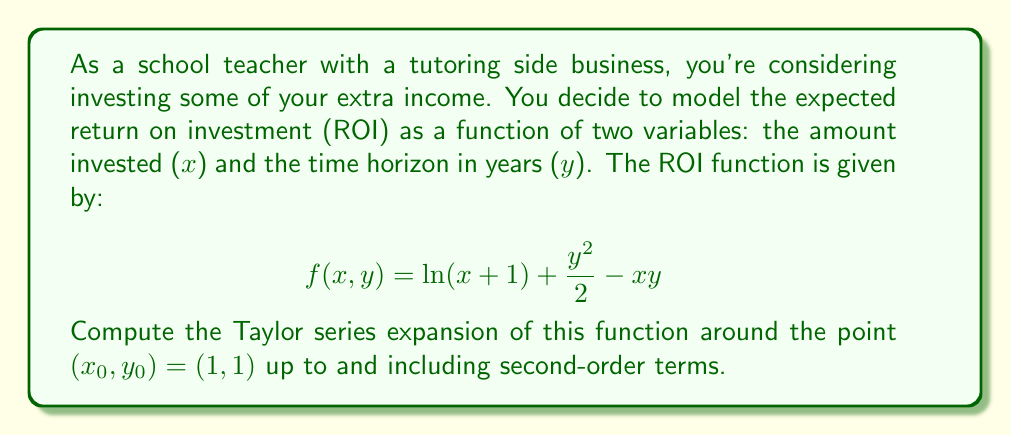Teach me how to tackle this problem. To find the Taylor series expansion of a multivariable function $f(x,y)$ around a point $(x_0, y_0)$, we use the formula:

$$f(x,y) \approx f(x_0, y_0) + f_x(x_0, y_0)(x-x_0) + f_y(x_0, y_0)(y-y_0) + \frac{1}{2!}[f_{xx}(x_0, y_0)(x-x_0)^2 + 2f_{xy}(x_0, y_0)(x-x_0)(y-y_0) + f_{yy}(x_0, y_0)(y-y_0)^2]$$

Let's compute each term:

1) $f(x_0, y_0) = f(1,1) = \ln(2) + \frac{1}{2} - 1 = \ln(2) - \frac{1}{2}$

2) $f_x(x,y) = \frac{1}{x+1} - y$
   $f_x(1,1) = \frac{1}{2} - 1 = -\frac{1}{2}$

3) $f_y(x,y) = y - x$
   $f_y(1,1) = 1 - 1 = 0$

4) $f_{xx}(x,y) = -\frac{1}{(x+1)^2}$
   $f_{xx}(1,1) = -\frac{1}{4}$

5) $f_{xy}(x,y) = -1$
   $f_{xy}(1,1) = -1$

6) $f_{yy}(x,y) = 1$
   $f_{yy}(1,1) = 1$

Now, let's substitute these values into the Taylor series formula:

$$f(x,y) \approx (\ln(2) - \frac{1}{2}) + (-\frac{1}{2})(x-1) + (0)(y-1) + \frac{1}{2}[(-\frac{1}{4})(x-1)^2 + 2(-1)(x-1)(y-1) + (1)(y-1)^2]$$

Simplifying:

$$f(x,y) \approx \ln(2) - \frac{1}{2} - \frac{1}{2}(x-1) - \frac{1}{8}(x-1)^2 - (x-1)(y-1) + \frac{1}{2}(y-1)^2$$
Answer: $$f(x,y) \approx \ln(2) - \frac{1}{2} - \frac{1}{2}(x-1) - \frac{1}{8}(x-1)^2 - (x-1)(y-1) + \frac{1}{2}(y-1)^2$$ 